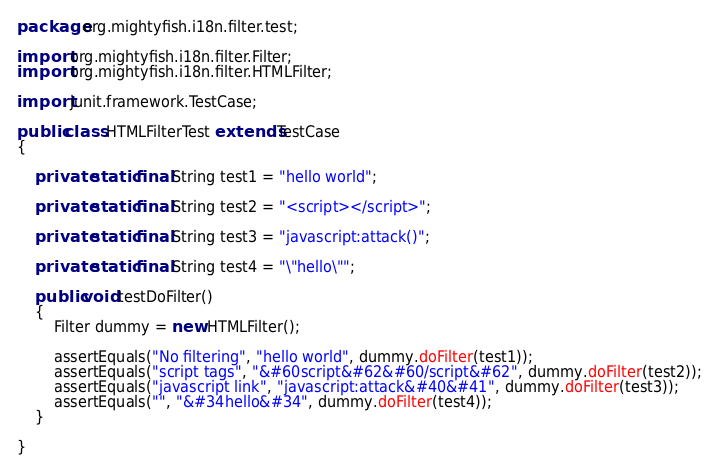Convert code to text. <code><loc_0><loc_0><loc_500><loc_500><_Java_>package org.mightyfish.i18n.filter.test;

import org.mightyfish.i18n.filter.Filter;
import org.mightyfish.i18n.filter.HTMLFilter;

import junit.framework.TestCase;

public class HTMLFilterTest extends TestCase
{

    private static final String test1 = "hello world";

    private static final String test2 = "<script></script>";

    private static final String test3 = "javascript:attack()";

    private static final String test4 = "\"hello\"";

    public void testDoFilter()
    {
        Filter dummy = new HTMLFilter();

        assertEquals("No filtering", "hello world", dummy.doFilter(test1));
        assertEquals("script tags", "&#60script&#62&#60/script&#62", dummy.doFilter(test2));
        assertEquals("javascript link", "javascript:attack&#40&#41", dummy.doFilter(test3));
        assertEquals("", "&#34hello&#34", dummy.doFilter(test4));
    }

}
</code> 